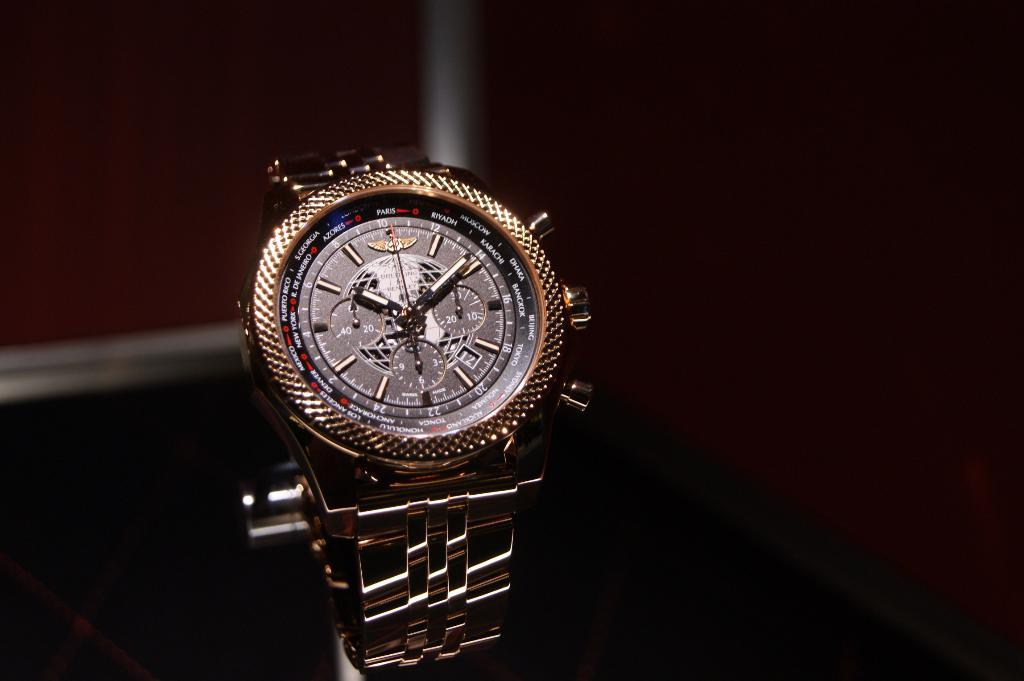<image>
Present a compact description of the photo's key features. Gold wrist watch that has the hands on the numbers 10 and 2. 